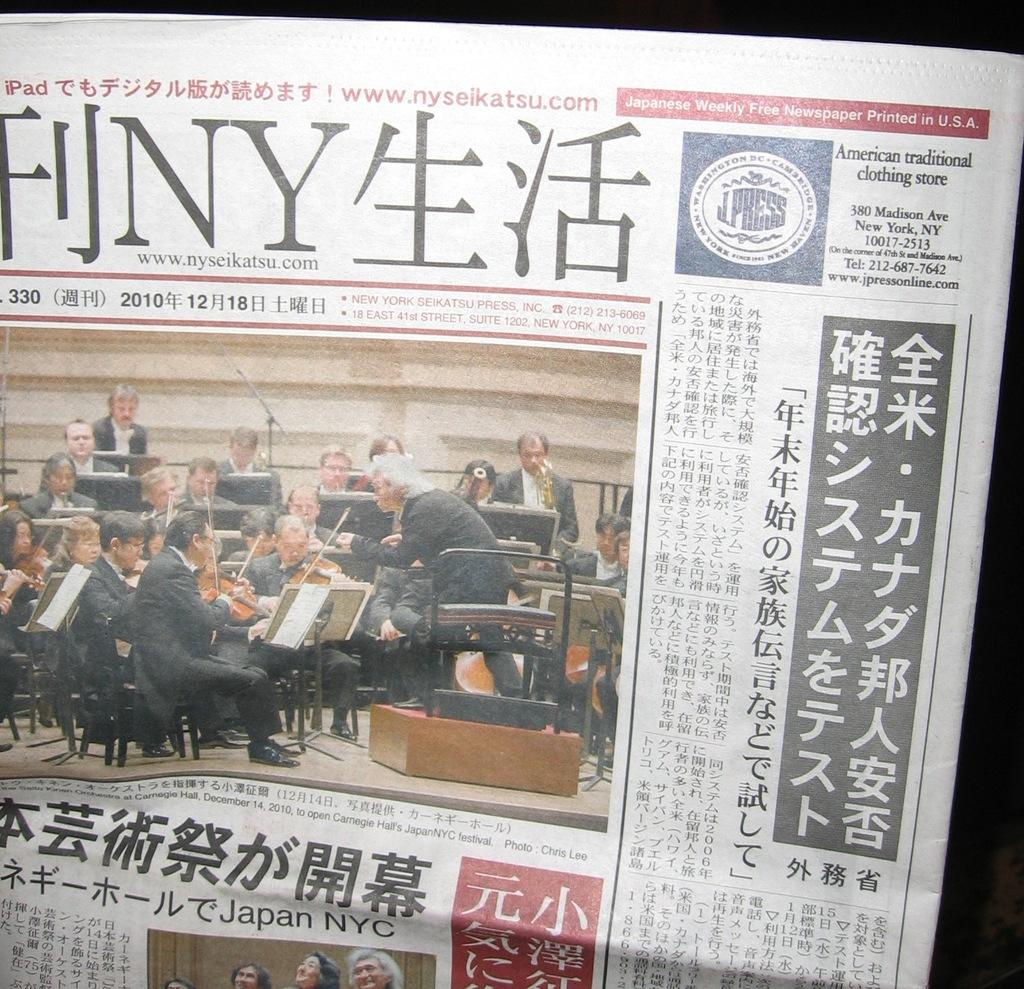<image>
Write a terse but informative summary of the picture. A newspaper in a foreign language with the address for a place in New York on the top right 